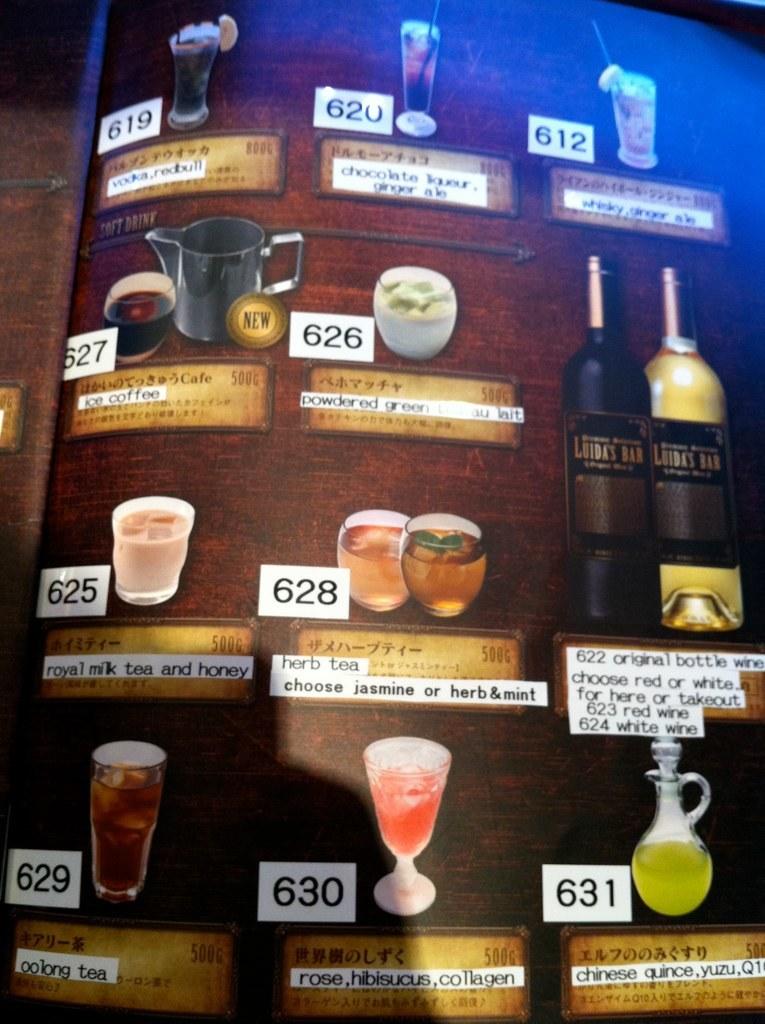How number is the pink drink on the bottom?
Your response must be concise. 630. What number is the herb tea?
Give a very brief answer. 628. 